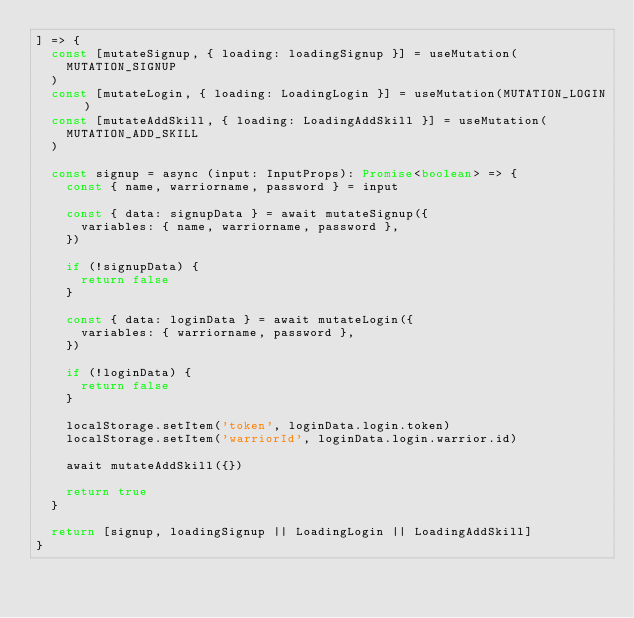<code> <loc_0><loc_0><loc_500><loc_500><_TypeScript_>] => {
  const [mutateSignup, { loading: loadingSignup }] = useMutation(
    MUTATION_SIGNUP
  )
  const [mutateLogin, { loading: LoadingLogin }] = useMutation(MUTATION_LOGIN)
  const [mutateAddSkill, { loading: LoadingAddSkill }] = useMutation(
    MUTATION_ADD_SKILL
  )

  const signup = async (input: InputProps): Promise<boolean> => {
    const { name, warriorname, password } = input

    const { data: signupData } = await mutateSignup({
      variables: { name, warriorname, password },
    })

    if (!signupData) {
      return false
    }

    const { data: loginData } = await mutateLogin({
      variables: { warriorname, password },
    })

    if (!loginData) {
      return false
    }

    localStorage.setItem('token', loginData.login.token)
    localStorage.setItem('warriorId', loginData.login.warrior.id)

    await mutateAddSkill({})

    return true
  }

  return [signup, loadingSignup || LoadingLogin || LoadingAddSkill]
}
</code> 